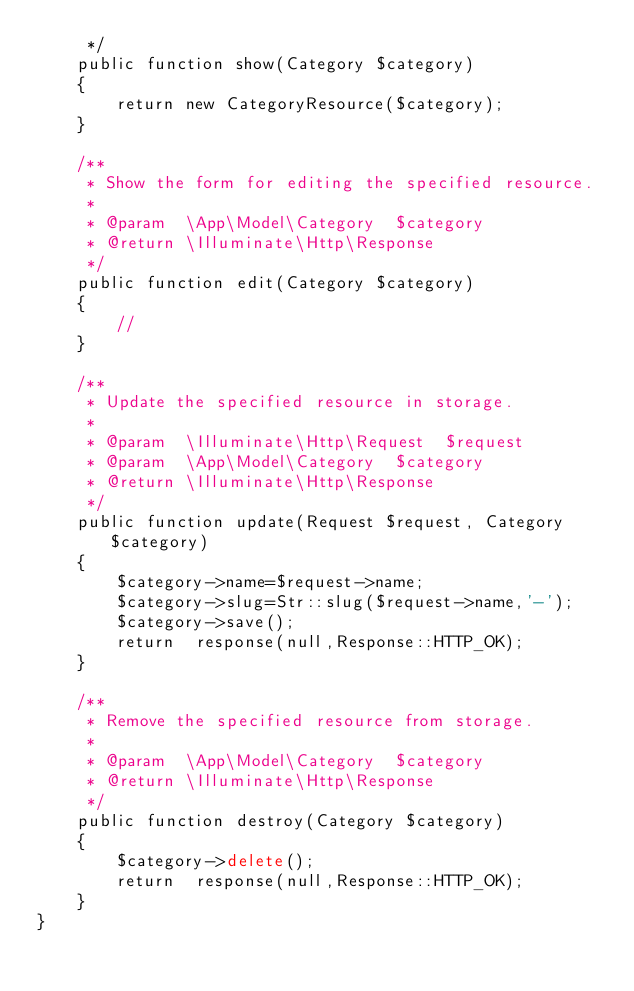<code> <loc_0><loc_0><loc_500><loc_500><_PHP_>     */
    public function show(Category $category)
    {
        return new CategoryResource($category);
    }

    /**
     * Show the form for editing the specified resource.
     *
     * @param  \App\Model\Category  $category
     * @return \Illuminate\Http\Response
     */
    public function edit(Category $category)
    {
        //
    }

    /**
     * Update the specified resource in storage.
     *
     * @param  \Illuminate\Http\Request  $request
     * @param  \App\Model\Category  $category
     * @return \Illuminate\Http\Response
     */
    public function update(Request $request, Category $category)
    {
        $category->name=$request->name;
        $category->slug=Str::slug($request->name,'-');
        $category->save();
        return  response(null,Response::HTTP_OK);
    }

    /**
     * Remove the specified resource from storage.
     *
     * @param  \App\Model\Category  $category
     * @return \Illuminate\Http\Response
     */
    public function destroy(Category $category)
    {
        $category->delete();
        return  response(null,Response::HTTP_OK);
    }
}
</code> 